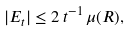Convert formula to latex. <formula><loc_0><loc_0><loc_500><loc_500>| E _ { t } | \leq 2 \, t ^ { - 1 } \, \mu ( { R } ) ,</formula> 